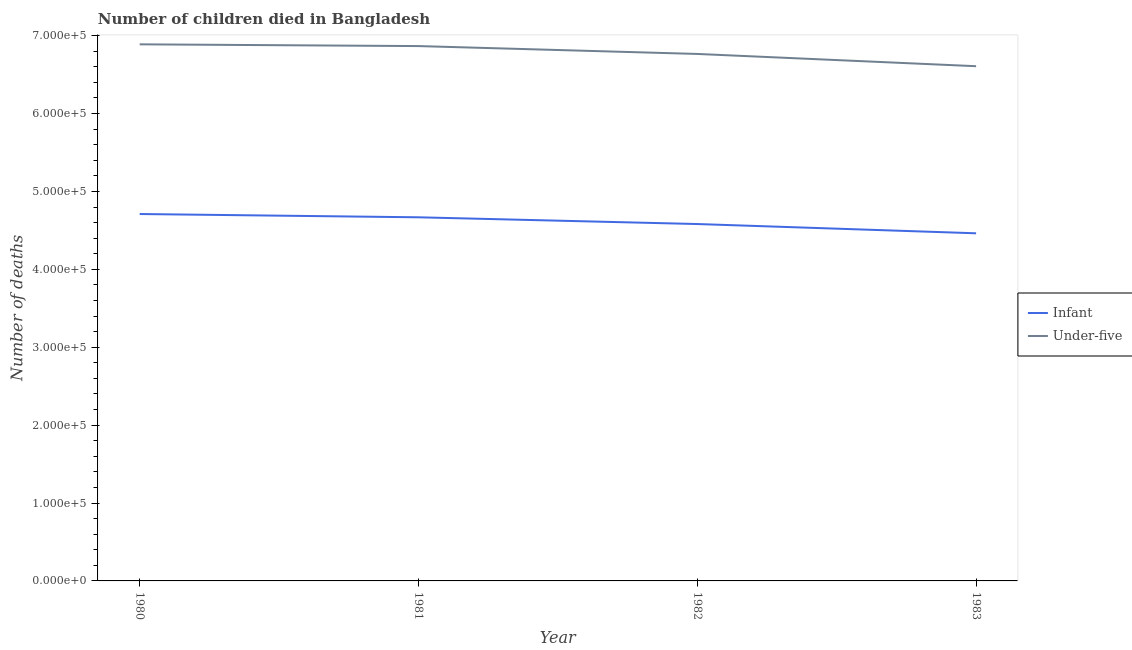How many different coloured lines are there?
Make the answer very short. 2. Does the line corresponding to number of under-five deaths intersect with the line corresponding to number of infant deaths?
Provide a short and direct response. No. Is the number of lines equal to the number of legend labels?
Give a very brief answer. Yes. What is the number of infant deaths in 1982?
Offer a very short reply. 4.58e+05. Across all years, what is the maximum number of under-five deaths?
Your answer should be very brief. 6.89e+05. Across all years, what is the minimum number of infant deaths?
Keep it short and to the point. 4.46e+05. In which year was the number of infant deaths maximum?
Make the answer very short. 1980. In which year was the number of infant deaths minimum?
Your answer should be compact. 1983. What is the total number of under-five deaths in the graph?
Provide a succinct answer. 2.71e+06. What is the difference between the number of infant deaths in 1982 and that in 1983?
Make the answer very short. 1.19e+04. What is the difference between the number of under-five deaths in 1980 and the number of infant deaths in 1983?
Provide a short and direct response. 2.43e+05. What is the average number of under-five deaths per year?
Make the answer very short. 6.78e+05. In the year 1981, what is the difference between the number of infant deaths and number of under-five deaths?
Ensure brevity in your answer.  -2.20e+05. In how many years, is the number of infant deaths greater than 320000?
Offer a very short reply. 4. What is the ratio of the number of infant deaths in 1981 to that in 1982?
Provide a short and direct response. 1.02. What is the difference between the highest and the second highest number of under-five deaths?
Your answer should be compact. 2255. What is the difference between the highest and the lowest number of under-five deaths?
Offer a terse response. 2.81e+04. Is the sum of the number of under-five deaths in 1981 and 1982 greater than the maximum number of infant deaths across all years?
Offer a terse response. Yes. How many lines are there?
Your response must be concise. 2. How many years are there in the graph?
Keep it short and to the point. 4. What is the difference between two consecutive major ticks on the Y-axis?
Your answer should be compact. 1.00e+05. Does the graph contain any zero values?
Give a very brief answer. No. How are the legend labels stacked?
Provide a succinct answer. Vertical. What is the title of the graph?
Ensure brevity in your answer.  Number of children died in Bangladesh. What is the label or title of the X-axis?
Your answer should be very brief. Year. What is the label or title of the Y-axis?
Your response must be concise. Number of deaths. What is the Number of deaths of Infant in 1980?
Offer a terse response. 4.71e+05. What is the Number of deaths in Under-five in 1980?
Provide a succinct answer. 6.89e+05. What is the Number of deaths of Infant in 1981?
Keep it short and to the point. 4.67e+05. What is the Number of deaths of Under-five in 1981?
Give a very brief answer. 6.87e+05. What is the Number of deaths of Infant in 1982?
Your answer should be very brief. 4.58e+05. What is the Number of deaths of Under-five in 1982?
Provide a short and direct response. 6.76e+05. What is the Number of deaths of Infant in 1983?
Your response must be concise. 4.46e+05. What is the Number of deaths in Under-five in 1983?
Make the answer very short. 6.61e+05. Across all years, what is the maximum Number of deaths of Infant?
Ensure brevity in your answer.  4.71e+05. Across all years, what is the maximum Number of deaths of Under-five?
Provide a succinct answer. 6.89e+05. Across all years, what is the minimum Number of deaths of Infant?
Make the answer very short. 4.46e+05. Across all years, what is the minimum Number of deaths of Under-five?
Your answer should be very brief. 6.61e+05. What is the total Number of deaths in Infant in the graph?
Provide a short and direct response. 1.84e+06. What is the total Number of deaths in Under-five in the graph?
Provide a succinct answer. 2.71e+06. What is the difference between the Number of deaths in Infant in 1980 and that in 1981?
Ensure brevity in your answer.  4223. What is the difference between the Number of deaths in Under-five in 1980 and that in 1981?
Provide a succinct answer. 2255. What is the difference between the Number of deaths of Infant in 1980 and that in 1982?
Keep it short and to the point. 1.29e+04. What is the difference between the Number of deaths in Under-five in 1980 and that in 1982?
Your answer should be compact. 1.24e+04. What is the difference between the Number of deaths in Infant in 1980 and that in 1983?
Offer a very short reply. 2.48e+04. What is the difference between the Number of deaths in Under-five in 1980 and that in 1983?
Provide a short and direct response. 2.81e+04. What is the difference between the Number of deaths of Infant in 1981 and that in 1982?
Your answer should be compact. 8636. What is the difference between the Number of deaths in Under-five in 1981 and that in 1982?
Ensure brevity in your answer.  1.01e+04. What is the difference between the Number of deaths in Infant in 1981 and that in 1983?
Ensure brevity in your answer.  2.05e+04. What is the difference between the Number of deaths of Under-five in 1981 and that in 1983?
Offer a very short reply. 2.58e+04. What is the difference between the Number of deaths of Infant in 1982 and that in 1983?
Provide a succinct answer. 1.19e+04. What is the difference between the Number of deaths of Under-five in 1982 and that in 1983?
Provide a succinct answer. 1.57e+04. What is the difference between the Number of deaths in Infant in 1980 and the Number of deaths in Under-five in 1981?
Your response must be concise. -2.16e+05. What is the difference between the Number of deaths of Infant in 1980 and the Number of deaths of Under-five in 1982?
Make the answer very short. -2.05e+05. What is the difference between the Number of deaths of Infant in 1980 and the Number of deaths of Under-five in 1983?
Keep it short and to the point. -1.90e+05. What is the difference between the Number of deaths of Infant in 1981 and the Number of deaths of Under-five in 1982?
Keep it short and to the point. -2.10e+05. What is the difference between the Number of deaths of Infant in 1981 and the Number of deaths of Under-five in 1983?
Provide a succinct answer. -1.94e+05. What is the difference between the Number of deaths of Infant in 1982 and the Number of deaths of Under-five in 1983?
Offer a terse response. -2.03e+05. What is the average Number of deaths in Infant per year?
Offer a terse response. 4.61e+05. What is the average Number of deaths of Under-five per year?
Provide a succinct answer. 6.78e+05. In the year 1980, what is the difference between the Number of deaths in Infant and Number of deaths in Under-five?
Give a very brief answer. -2.18e+05. In the year 1981, what is the difference between the Number of deaths of Infant and Number of deaths of Under-five?
Your answer should be compact. -2.20e+05. In the year 1982, what is the difference between the Number of deaths of Infant and Number of deaths of Under-five?
Provide a short and direct response. -2.18e+05. In the year 1983, what is the difference between the Number of deaths in Infant and Number of deaths in Under-five?
Your response must be concise. -2.15e+05. What is the ratio of the Number of deaths of Infant in 1980 to that in 1981?
Offer a terse response. 1.01. What is the ratio of the Number of deaths in Infant in 1980 to that in 1982?
Your response must be concise. 1.03. What is the ratio of the Number of deaths in Under-five in 1980 to that in 1982?
Make the answer very short. 1.02. What is the ratio of the Number of deaths of Infant in 1980 to that in 1983?
Ensure brevity in your answer.  1.06. What is the ratio of the Number of deaths in Under-five in 1980 to that in 1983?
Provide a short and direct response. 1.04. What is the ratio of the Number of deaths in Infant in 1981 to that in 1982?
Offer a terse response. 1.02. What is the ratio of the Number of deaths of Under-five in 1981 to that in 1982?
Make the answer very short. 1.01. What is the ratio of the Number of deaths of Infant in 1981 to that in 1983?
Ensure brevity in your answer.  1.05. What is the ratio of the Number of deaths in Under-five in 1981 to that in 1983?
Keep it short and to the point. 1.04. What is the ratio of the Number of deaths of Infant in 1982 to that in 1983?
Your answer should be compact. 1.03. What is the ratio of the Number of deaths of Under-five in 1982 to that in 1983?
Offer a very short reply. 1.02. What is the difference between the highest and the second highest Number of deaths in Infant?
Your answer should be very brief. 4223. What is the difference between the highest and the second highest Number of deaths in Under-five?
Offer a very short reply. 2255. What is the difference between the highest and the lowest Number of deaths in Infant?
Provide a short and direct response. 2.48e+04. What is the difference between the highest and the lowest Number of deaths of Under-five?
Offer a terse response. 2.81e+04. 